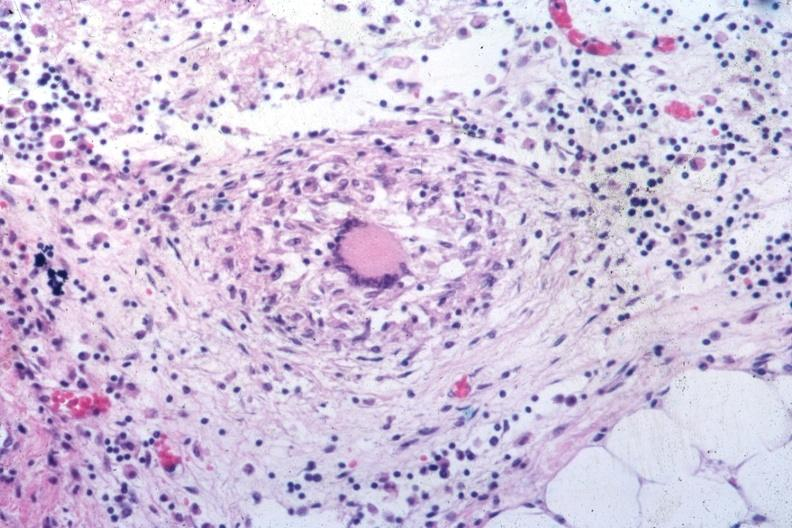what does this image show?
Answer the question using a single word or phrase. Outstanding example of a tubercular granuloma same as in slide seen at low classical granuloma with langhans giant cell 